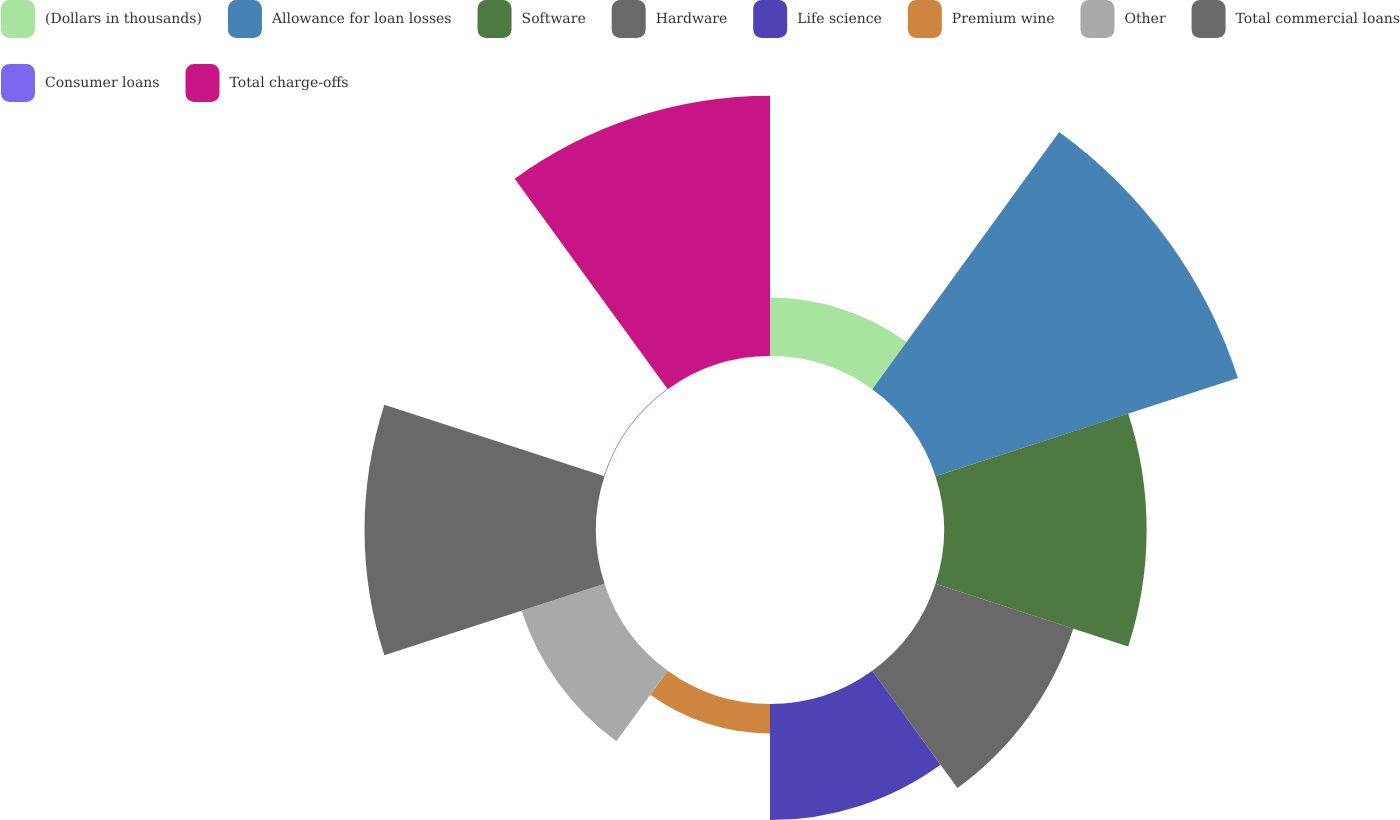Convert chart to OTSL. <chart><loc_0><loc_0><loc_500><loc_500><pie_chart><fcel>(Dollars in thousands)<fcel>Allowance for loan losses<fcel>Software<fcel>Hardware<fcel>Life science<fcel>Premium wine<fcel>Other<fcel>Total commercial loans<fcel>Consumer loans<fcel>Total charge-offs<nl><fcel>4.03%<fcel>21.94%<fcel>13.98%<fcel>10.0%<fcel>8.01%<fcel>2.04%<fcel>6.02%<fcel>15.97%<fcel>0.05%<fcel>17.96%<nl></chart> 